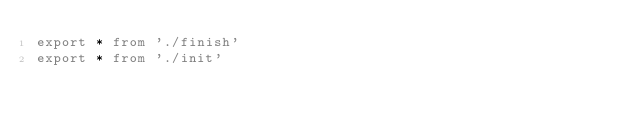Convert code to text. <code><loc_0><loc_0><loc_500><loc_500><_TypeScript_>export * from './finish'
export * from './init'
</code> 